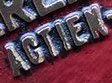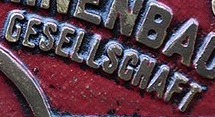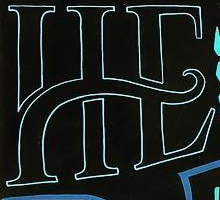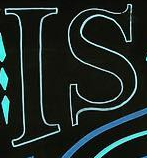What words are shown in these images in order, separated by a semicolon? AGTIEN; GESELLSGNAFT; HE; IS 